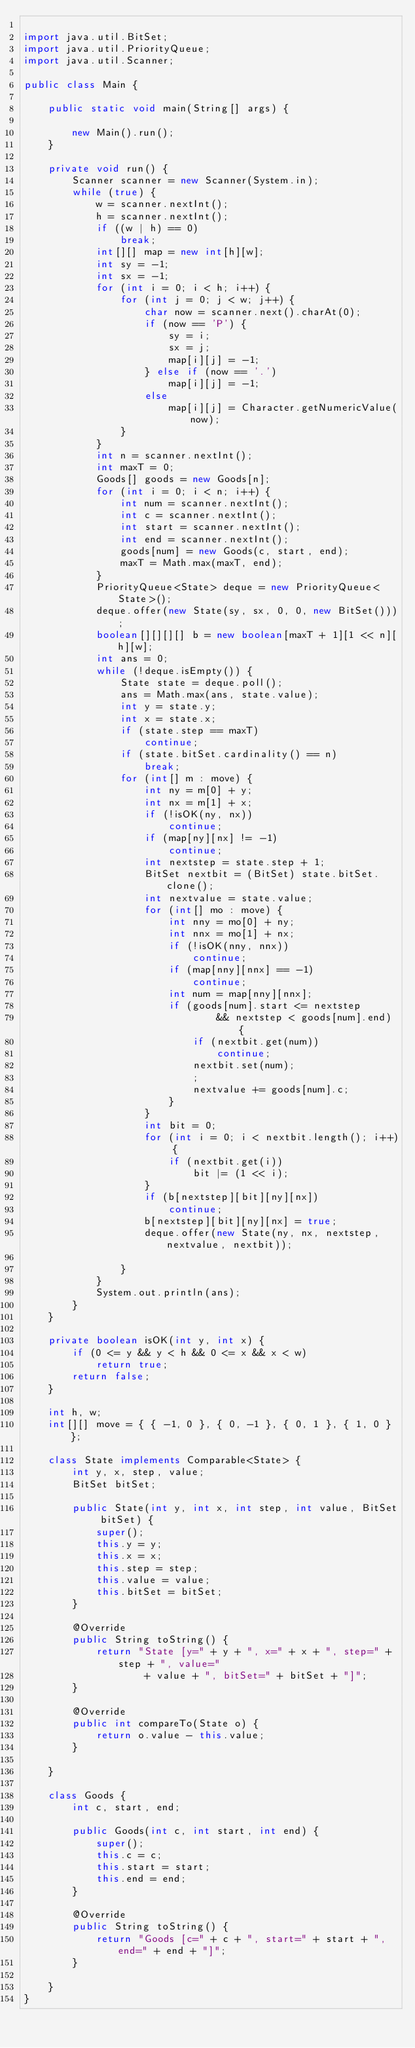<code> <loc_0><loc_0><loc_500><loc_500><_Java_>
import java.util.BitSet;
import java.util.PriorityQueue;
import java.util.Scanner;

public class Main {

	public static void main(String[] args) {

		new Main().run();
	}

	private void run() {
		Scanner scanner = new Scanner(System.in);
		while (true) {
			w = scanner.nextInt();
			h = scanner.nextInt();
			if ((w | h) == 0)
				break;
			int[][] map = new int[h][w];
			int sy = -1;
			int sx = -1;
			for (int i = 0; i < h; i++) {
				for (int j = 0; j < w; j++) {
					char now = scanner.next().charAt(0);
					if (now == 'P') {
						sy = i;
						sx = j;
						map[i][j] = -1;
					} else if (now == '.')
						map[i][j] = -1;
					else
						map[i][j] = Character.getNumericValue(now);
				}
			}
			int n = scanner.nextInt();
			int maxT = 0;
			Goods[] goods = new Goods[n];
			for (int i = 0; i < n; i++) {
				int num = scanner.nextInt();
				int c = scanner.nextInt();
				int start = scanner.nextInt();
				int end = scanner.nextInt();
				goods[num] = new Goods(c, start, end);
				maxT = Math.max(maxT, end);
			}
			PriorityQueue<State> deque = new PriorityQueue<State>();
			deque.offer(new State(sy, sx, 0, 0, new BitSet()));
			boolean[][][][] b = new boolean[maxT + 1][1 << n][h][w];
			int ans = 0;
			while (!deque.isEmpty()) {
				State state = deque.poll();
				ans = Math.max(ans, state.value);
				int y = state.y;
				int x = state.x;
				if (state.step == maxT)
					continue;
				if (state.bitSet.cardinality() == n)
					break;
				for (int[] m : move) {
					int ny = m[0] + y;
					int nx = m[1] + x;
					if (!isOK(ny, nx))
						continue;
					if (map[ny][nx] != -1)
						continue;
					int nextstep = state.step + 1;
					BitSet nextbit = (BitSet) state.bitSet.clone();
					int nextvalue = state.value;
					for (int[] mo : move) {
						int nny = mo[0] + ny;
						int nnx = mo[1] + nx;
						if (!isOK(nny, nnx))
							continue;
						if (map[nny][nnx] == -1)
							continue;
						int num = map[nny][nnx];
						if (goods[num].start <= nextstep
								&& nextstep < goods[num].end) {
							if (nextbit.get(num))
								continue;
							nextbit.set(num);
							;
							nextvalue += goods[num].c;
						}
					}
					int bit = 0;
					for (int i = 0; i < nextbit.length(); i++) {
						if (nextbit.get(i))
							bit |= (1 << i);
					}
					if (b[nextstep][bit][ny][nx])
						continue;
					b[nextstep][bit][ny][nx] = true;
					deque.offer(new State(ny, nx, nextstep, nextvalue, nextbit));

				}
			}
			System.out.println(ans);
		}
	}

	private boolean isOK(int y, int x) {
		if (0 <= y && y < h && 0 <= x && x < w)
			return true;
		return false;
	}

	int h, w;
	int[][] move = { { -1, 0 }, { 0, -1 }, { 0, 1 }, { 1, 0 } };

	class State implements Comparable<State> {
		int y, x, step, value;
		BitSet bitSet;

		public State(int y, int x, int step, int value, BitSet bitSet) {
			super();
			this.y = y;
			this.x = x;
			this.step = step;
			this.value = value;
			this.bitSet = bitSet;
		}

		@Override
		public String toString() {
			return "State [y=" + y + ", x=" + x + ", step=" + step + ", value="
					+ value + ", bitSet=" + bitSet + "]";
		}

		@Override
		public int compareTo(State o) {
			return o.value - this.value;
		}

	}

	class Goods {
		int c, start, end;

		public Goods(int c, int start, int end) {
			super();
			this.c = c;
			this.start = start;
			this.end = end;
		}

		@Override
		public String toString() {
			return "Goods [c=" + c + ", start=" + start + ", end=" + end + "]";
		}

	}
}</code> 